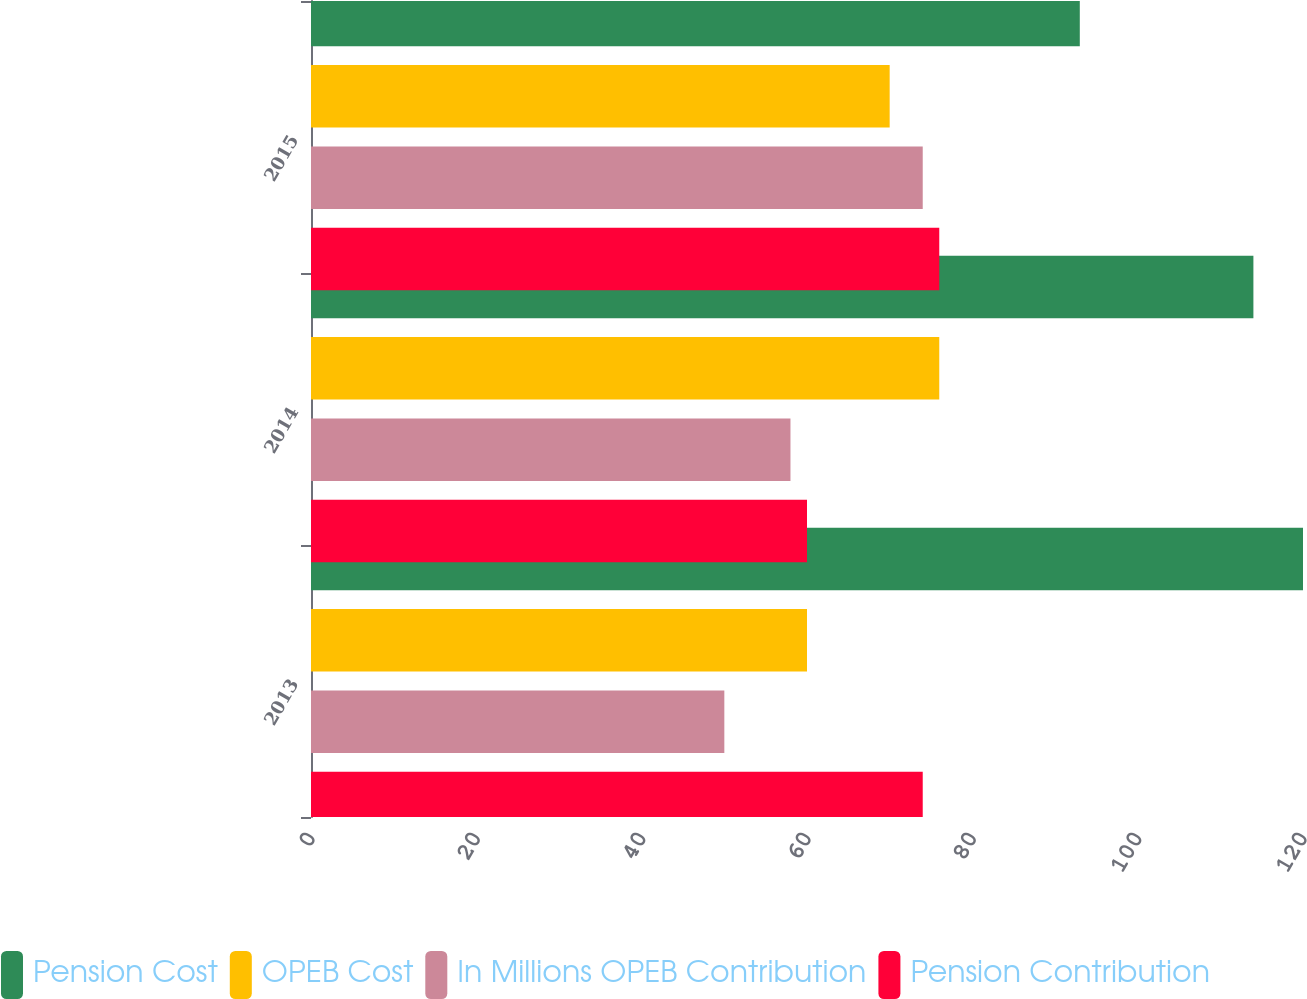<chart> <loc_0><loc_0><loc_500><loc_500><stacked_bar_chart><ecel><fcel>2013<fcel>2014<fcel>2015<nl><fcel>Pension Cost<fcel>120<fcel>114<fcel>93<nl><fcel>OPEB Cost<fcel>60<fcel>76<fcel>70<nl><fcel>In Millions OPEB Contribution<fcel>50<fcel>58<fcel>74<nl><fcel>Pension Contribution<fcel>74<fcel>60<fcel>76<nl></chart> 